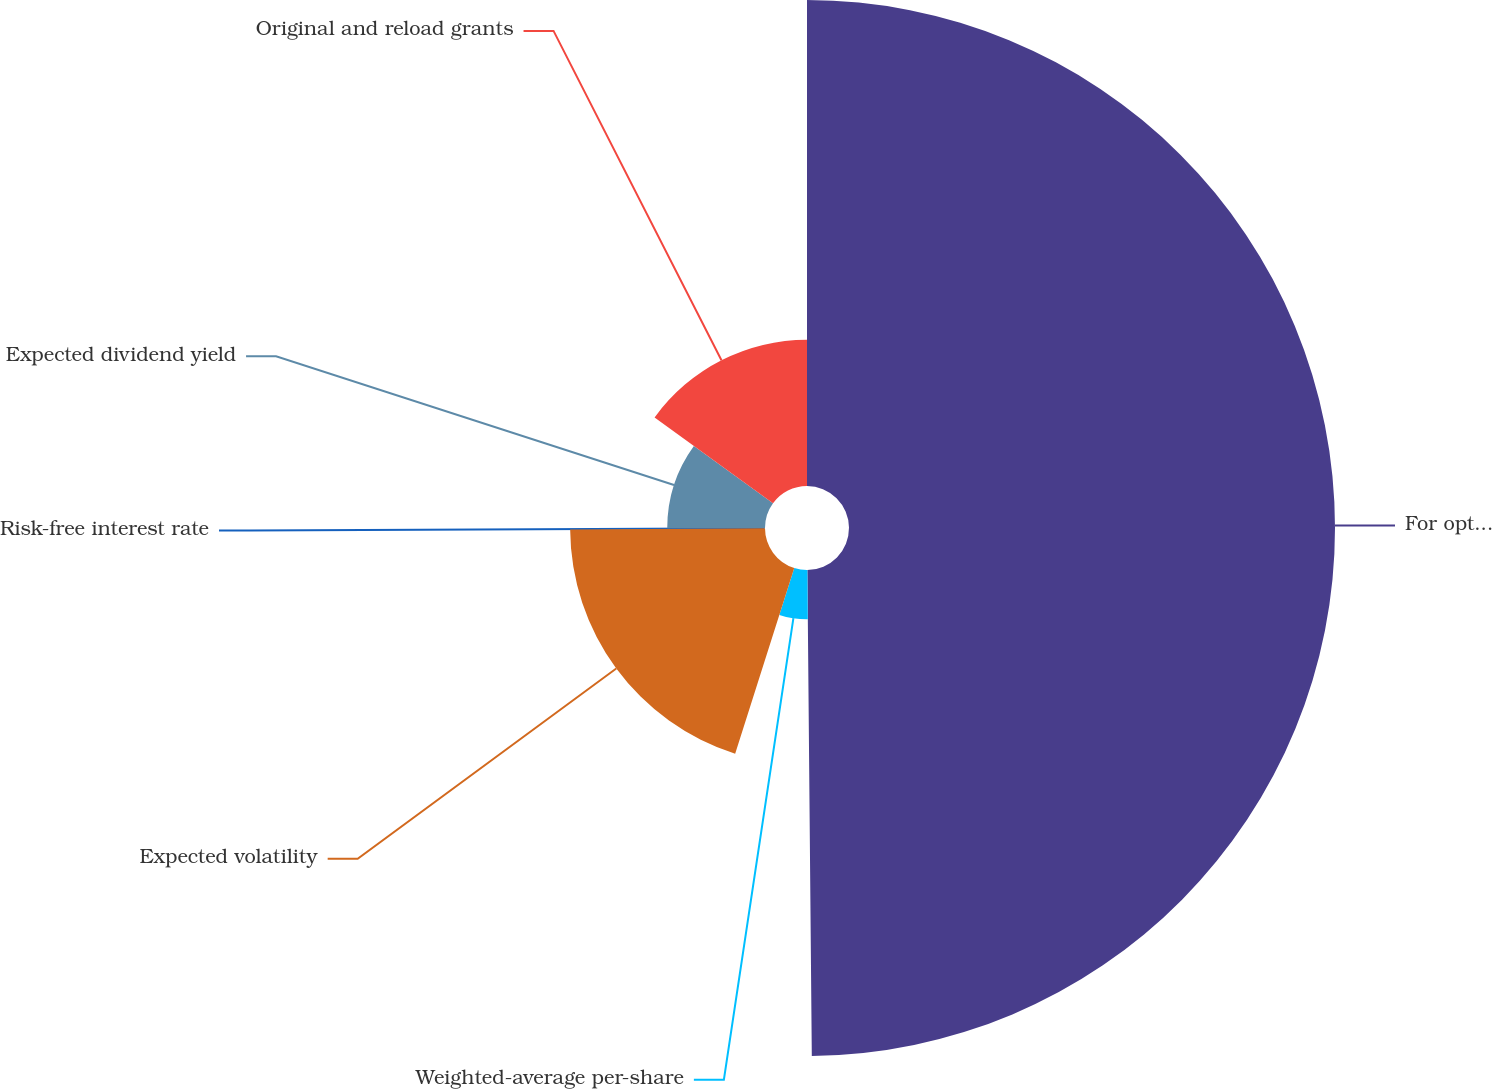Convert chart to OTSL. <chart><loc_0><loc_0><loc_500><loc_500><pie_chart><fcel>For options granted during<fcel>Weighted-average per-share<fcel>Expected volatility<fcel>Risk-free interest rate<fcel>Expected dividend yield<fcel>Original and reload grants<nl><fcel>49.86%<fcel>5.05%<fcel>19.99%<fcel>0.07%<fcel>10.03%<fcel>15.01%<nl></chart> 